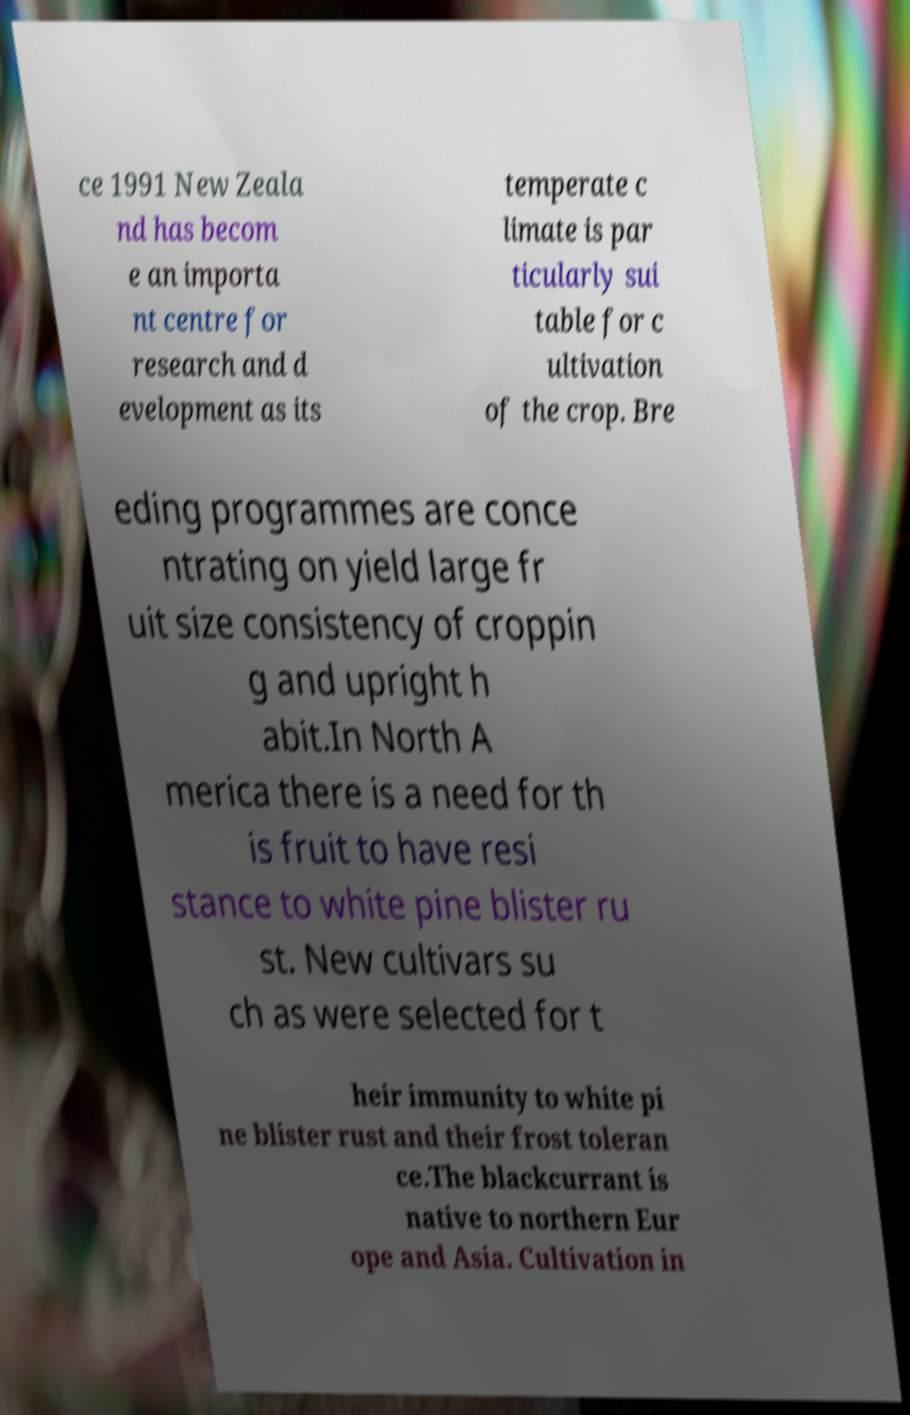Could you assist in decoding the text presented in this image and type it out clearly? ce 1991 New Zeala nd has becom e an importa nt centre for research and d evelopment as its temperate c limate is par ticularly sui table for c ultivation of the crop. Bre eding programmes are conce ntrating on yield large fr uit size consistency of croppin g and upright h abit.In North A merica there is a need for th is fruit to have resi stance to white pine blister ru st. New cultivars su ch as were selected for t heir immunity to white pi ne blister rust and their frost toleran ce.The blackcurrant is native to northern Eur ope and Asia. Cultivation in 